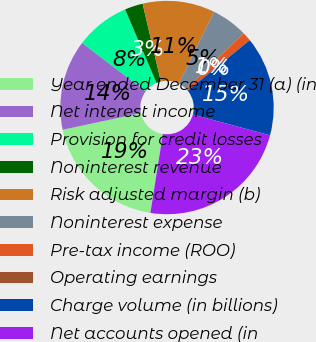<chart> <loc_0><loc_0><loc_500><loc_500><pie_chart><fcel>Year ended December 31 (a) (in<fcel>Net interest income<fcel>Provision for credit losses<fcel>Noninterest revenue<fcel>Risk adjusted margin (b)<fcel>Noninterest expense<fcel>Pre-tax income (ROO)<fcel>Operating earnings<fcel>Charge volume (in billions)<fcel>Net accounts opened (in<nl><fcel>19.18%<fcel>13.7%<fcel>8.22%<fcel>2.74%<fcel>10.96%<fcel>5.48%<fcel>1.37%<fcel>0.0%<fcel>15.07%<fcel>23.29%<nl></chart> 